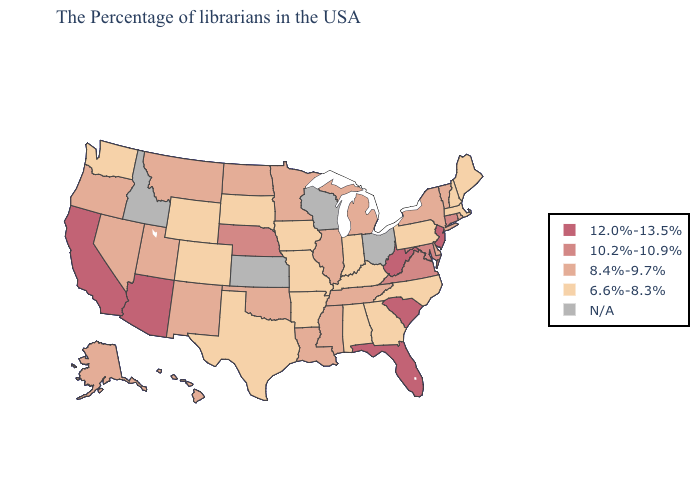Does the first symbol in the legend represent the smallest category?
Keep it brief. No. Which states hav the highest value in the Northeast?
Short answer required. New Jersey. Among the states that border South Dakota , does Nebraska have the highest value?
Write a very short answer. Yes. Does Massachusetts have the lowest value in the Northeast?
Be succinct. Yes. What is the lowest value in the USA?
Concise answer only. 6.6%-8.3%. What is the highest value in the USA?
Give a very brief answer. 12.0%-13.5%. What is the value of Virginia?
Keep it brief. 10.2%-10.9%. How many symbols are there in the legend?
Quick response, please. 5. Does Kentucky have the lowest value in the USA?
Concise answer only. Yes. Name the states that have a value in the range 10.2%-10.9%?
Short answer required. Connecticut, Maryland, Virginia, Nebraska. What is the highest value in the West ?
Give a very brief answer. 12.0%-13.5%. Which states have the highest value in the USA?
Short answer required. New Jersey, South Carolina, West Virginia, Florida, Arizona, California. Name the states that have a value in the range N/A?
Answer briefly. Ohio, Wisconsin, Kansas, Idaho. Is the legend a continuous bar?
Be succinct. No. 